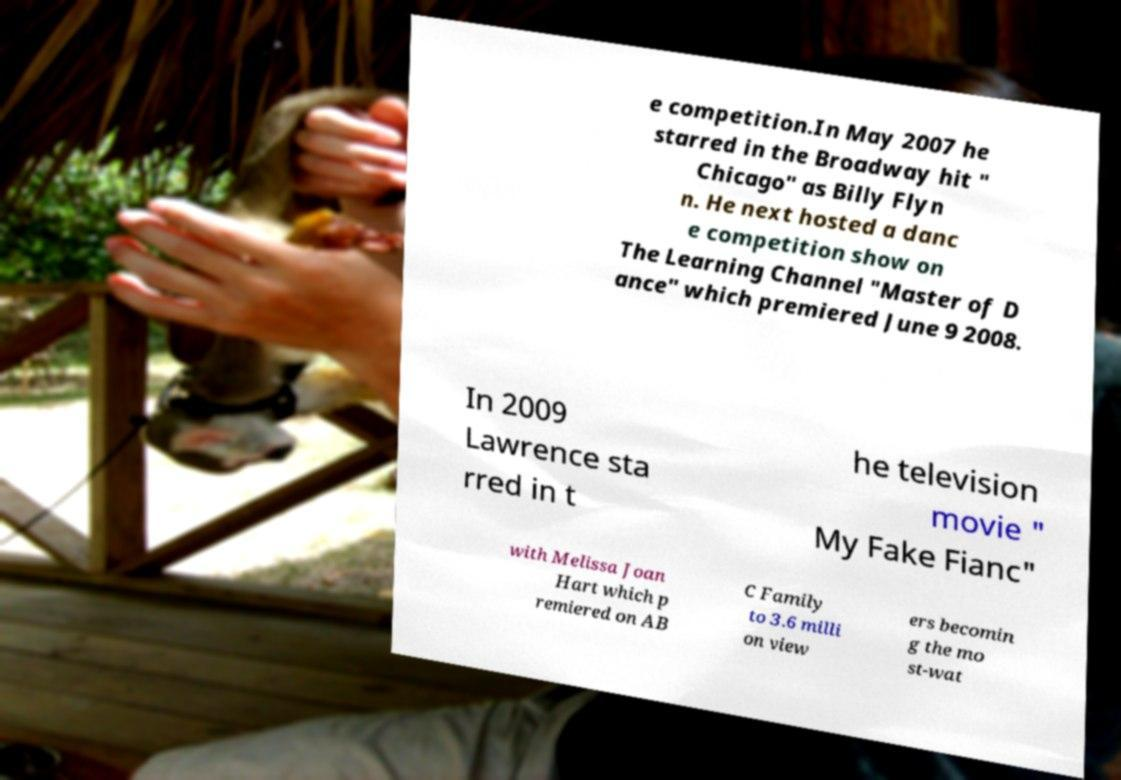I need the written content from this picture converted into text. Can you do that? e competition.In May 2007 he starred in the Broadway hit " Chicago" as Billy Flyn n. He next hosted a danc e competition show on The Learning Channel "Master of D ance" which premiered June 9 2008. In 2009 Lawrence sta rred in t he television movie " My Fake Fianc" with Melissa Joan Hart which p remiered on AB C Family to 3.6 milli on view ers becomin g the mo st-wat 